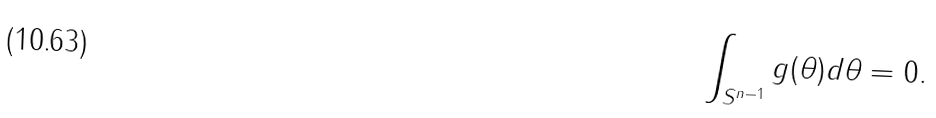Convert formula to latex. <formula><loc_0><loc_0><loc_500><loc_500>\int _ { S ^ { n - 1 } } g ( \theta ) d \theta = 0 .</formula> 